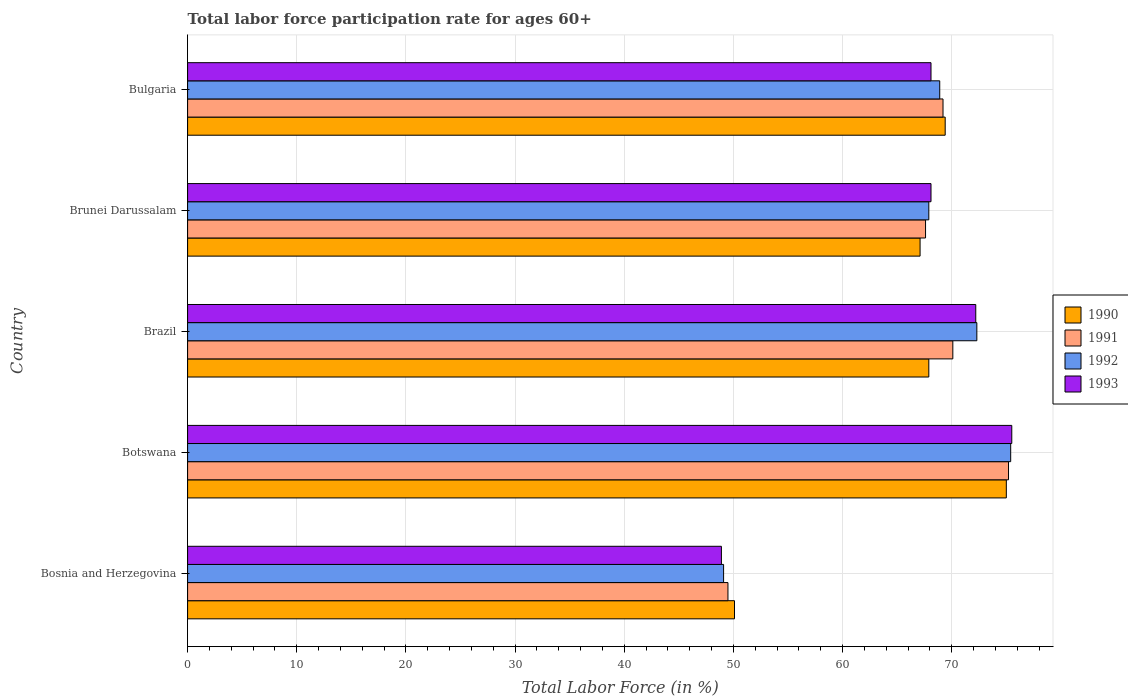How many groups of bars are there?
Provide a succinct answer. 5. Are the number of bars per tick equal to the number of legend labels?
Provide a short and direct response. Yes. Are the number of bars on each tick of the Y-axis equal?
Offer a terse response. Yes. How many bars are there on the 3rd tick from the top?
Your response must be concise. 4. What is the label of the 5th group of bars from the top?
Your answer should be compact. Bosnia and Herzegovina. In how many cases, is the number of bars for a given country not equal to the number of legend labels?
Make the answer very short. 0. What is the labor force participation rate in 1992 in Brazil?
Ensure brevity in your answer.  72.3. Across all countries, what is the maximum labor force participation rate in 1991?
Your answer should be very brief. 75.2. Across all countries, what is the minimum labor force participation rate in 1990?
Your response must be concise. 50.1. In which country was the labor force participation rate in 1990 maximum?
Your answer should be very brief. Botswana. In which country was the labor force participation rate in 1990 minimum?
Give a very brief answer. Bosnia and Herzegovina. What is the total labor force participation rate in 1990 in the graph?
Ensure brevity in your answer.  329.5. What is the difference between the labor force participation rate in 1991 in Bosnia and Herzegovina and that in Brunei Darussalam?
Offer a very short reply. -18.1. What is the difference between the labor force participation rate in 1990 in Botswana and the labor force participation rate in 1992 in Bulgaria?
Your answer should be very brief. 6.1. What is the average labor force participation rate in 1992 per country?
Offer a terse response. 66.72. What is the ratio of the labor force participation rate in 1991 in Botswana to that in Bulgaria?
Make the answer very short. 1.09. Is the labor force participation rate in 1991 in Bosnia and Herzegovina less than that in Botswana?
Your response must be concise. Yes. What is the difference between the highest and the second highest labor force participation rate in 1993?
Provide a short and direct response. 3.3. What is the difference between the highest and the lowest labor force participation rate in 1991?
Ensure brevity in your answer.  25.7. In how many countries, is the labor force participation rate in 1992 greater than the average labor force participation rate in 1992 taken over all countries?
Your answer should be compact. 4. Is it the case that in every country, the sum of the labor force participation rate in 1992 and labor force participation rate in 1993 is greater than the sum of labor force participation rate in 1991 and labor force participation rate in 1990?
Keep it short and to the point. No. What does the 4th bar from the bottom in Brunei Darussalam represents?
Ensure brevity in your answer.  1993. Is it the case that in every country, the sum of the labor force participation rate in 1993 and labor force participation rate in 1990 is greater than the labor force participation rate in 1992?
Your response must be concise. Yes. How many countries are there in the graph?
Give a very brief answer. 5. What is the difference between two consecutive major ticks on the X-axis?
Provide a short and direct response. 10. Where does the legend appear in the graph?
Offer a very short reply. Center right. How are the legend labels stacked?
Offer a terse response. Vertical. What is the title of the graph?
Provide a succinct answer. Total labor force participation rate for ages 60+. What is the Total Labor Force (in %) of 1990 in Bosnia and Herzegovina?
Give a very brief answer. 50.1. What is the Total Labor Force (in %) in 1991 in Bosnia and Herzegovina?
Keep it short and to the point. 49.5. What is the Total Labor Force (in %) in 1992 in Bosnia and Herzegovina?
Provide a succinct answer. 49.1. What is the Total Labor Force (in %) in 1993 in Bosnia and Herzegovina?
Make the answer very short. 48.9. What is the Total Labor Force (in %) in 1990 in Botswana?
Your response must be concise. 75. What is the Total Labor Force (in %) of 1991 in Botswana?
Keep it short and to the point. 75.2. What is the Total Labor Force (in %) in 1992 in Botswana?
Give a very brief answer. 75.4. What is the Total Labor Force (in %) in 1993 in Botswana?
Offer a very short reply. 75.5. What is the Total Labor Force (in %) of 1990 in Brazil?
Ensure brevity in your answer.  67.9. What is the Total Labor Force (in %) of 1991 in Brazil?
Offer a terse response. 70.1. What is the Total Labor Force (in %) in 1992 in Brazil?
Offer a terse response. 72.3. What is the Total Labor Force (in %) in 1993 in Brazil?
Provide a succinct answer. 72.2. What is the Total Labor Force (in %) of 1990 in Brunei Darussalam?
Make the answer very short. 67.1. What is the Total Labor Force (in %) of 1991 in Brunei Darussalam?
Keep it short and to the point. 67.6. What is the Total Labor Force (in %) in 1992 in Brunei Darussalam?
Your response must be concise. 67.9. What is the Total Labor Force (in %) of 1993 in Brunei Darussalam?
Ensure brevity in your answer.  68.1. What is the Total Labor Force (in %) of 1990 in Bulgaria?
Ensure brevity in your answer.  69.4. What is the Total Labor Force (in %) of 1991 in Bulgaria?
Offer a terse response. 69.2. What is the Total Labor Force (in %) of 1992 in Bulgaria?
Provide a succinct answer. 68.9. What is the Total Labor Force (in %) of 1993 in Bulgaria?
Keep it short and to the point. 68.1. Across all countries, what is the maximum Total Labor Force (in %) in 1990?
Provide a succinct answer. 75. Across all countries, what is the maximum Total Labor Force (in %) of 1991?
Offer a terse response. 75.2. Across all countries, what is the maximum Total Labor Force (in %) in 1992?
Give a very brief answer. 75.4. Across all countries, what is the maximum Total Labor Force (in %) of 1993?
Provide a short and direct response. 75.5. Across all countries, what is the minimum Total Labor Force (in %) of 1990?
Offer a terse response. 50.1. Across all countries, what is the minimum Total Labor Force (in %) of 1991?
Provide a short and direct response. 49.5. Across all countries, what is the minimum Total Labor Force (in %) of 1992?
Ensure brevity in your answer.  49.1. Across all countries, what is the minimum Total Labor Force (in %) in 1993?
Offer a very short reply. 48.9. What is the total Total Labor Force (in %) of 1990 in the graph?
Provide a short and direct response. 329.5. What is the total Total Labor Force (in %) of 1991 in the graph?
Offer a terse response. 331.6. What is the total Total Labor Force (in %) of 1992 in the graph?
Your answer should be compact. 333.6. What is the total Total Labor Force (in %) of 1993 in the graph?
Keep it short and to the point. 332.8. What is the difference between the Total Labor Force (in %) of 1990 in Bosnia and Herzegovina and that in Botswana?
Your answer should be compact. -24.9. What is the difference between the Total Labor Force (in %) of 1991 in Bosnia and Herzegovina and that in Botswana?
Give a very brief answer. -25.7. What is the difference between the Total Labor Force (in %) in 1992 in Bosnia and Herzegovina and that in Botswana?
Keep it short and to the point. -26.3. What is the difference between the Total Labor Force (in %) of 1993 in Bosnia and Herzegovina and that in Botswana?
Your answer should be very brief. -26.6. What is the difference between the Total Labor Force (in %) in 1990 in Bosnia and Herzegovina and that in Brazil?
Make the answer very short. -17.8. What is the difference between the Total Labor Force (in %) in 1991 in Bosnia and Herzegovina and that in Brazil?
Offer a terse response. -20.6. What is the difference between the Total Labor Force (in %) of 1992 in Bosnia and Herzegovina and that in Brazil?
Provide a short and direct response. -23.2. What is the difference between the Total Labor Force (in %) of 1993 in Bosnia and Herzegovina and that in Brazil?
Offer a terse response. -23.3. What is the difference between the Total Labor Force (in %) of 1990 in Bosnia and Herzegovina and that in Brunei Darussalam?
Make the answer very short. -17. What is the difference between the Total Labor Force (in %) in 1991 in Bosnia and Herzegovina and that in Brunei Darussalam?
Your answer should be very brief. -18.1. What is the difference between the Total Labor Force (in %) in 1992 in Bosnia and Herzegovina and that in Brunei Darussalam?
Your answer should be very brief. -18.8. What is the difference between the Total Labor Force (in %) in 1993 in Bosnia and Herzegovina and that in Brunei Darussalam?
Give a very brief answer. -19.2. What is the difference between the Total Labor Force (in %) in 1990 in Bosnia and Herzegovina and that in Bulgaria?
Make the answer very short. -19.3. What is the difference between the Total Labor Force (in %) of 1991 in Bosnia and Herzegovina and that in Bulgaria?
Give a very brief answer. -19.7. What is the difference between the Total Labor Force (in %) in 1992 in Bosnia and Herzegovina and that in Bulgaria?
Keep it short and to the point. -19.8. What is the difference between the Total Labor Force (in %) of 1993 in Bosnia and Herzegovina and that in Bulgaria?
Provide a succinct answer. -19.2. What is the difference between the Total Labor Force (in %) in 1993 in Botswana and that in Brazil?
Your answer should be very brief. 3.3. What is the difference between the Total Labor Force (in %) of 1990 in Botswana and that in Brunei Darussalam?
Your answer should be compact. 7.9. What is the difference between the Total Labor Force (in %) in 1991 in Botswana and that in Brunei Darussalam?
Your answer should be very brief. 7.6. What is the difference between the Total Labor Force (in %) in 1993 in Botswana and that in Brunei Darussalam?
Provide a short and direct response. 7.4. What is the difference between the Total Labor Force (in %) of 1990 in Botswana and that in Bulgaria?
Ensure brevity in your answer.  5.6. What is the difference between the Total Labor Force (in %) of 1993 in Botswana and that in Bulgaria?
Make the answer very short. 7.4. What is the difference between the Total Labor Force (in %) in 1990 in Brazil and that in Brunei Darussalam?
Make the answer very short. 0.8. What is the difference between the Total Labor Force (in %) of 1993 in Brazil and that in Brunei Darussalam?
Provide a succinct answer. 4.1. What is the difference between the Total Labor Force (in %) of 1992 in Brazil and that in Bulgaria?
Provide a succinct answer. 3.4. What is the difference between the Total Labor Force (in %) of 1991 in Brunei Darussalam and that in Bulgaria?
Provide a short and direct response. -1.6. What is the difference between the Total Labor Force (in %) of 1992 in Brunei Darussalam and that in Bulgaria?
Your answer should be very brief. -1. What is the difference between the Total Labor Force (in %) of 1993 in Brunei Darussalam and that in Bulgaria?
Offer a terse response. 0. What is the difference between the Total Labor Force (in %) in 1990 in Bosnia and Herzegovina and the Total Labor Force (in %) in 1991 in Botswana?
Offer a terse response. -25.1. What is the difference between the Total Labor Force (in %) in 1990 in Bosnia and Herzegovina and the Total Labor Force (in %) in 1992 in Botswana?
Give a very brief answer. -25.3. What is the difference between the Total Labor Force (in %) in 1990 in Bosnia and Herzegovina and the Total Labor Force (in %) in 1993 in Botswana?
Give a very brief answer. -25.4. What is the difference between the Total Labor Force (in %) in 1991 in Bosnia and Herzegovina and the Total Labor Force (in %) in 1992 in Botswana?
Your answer should be compact. -25.9. What is the difference between the Total Labor Force (in %) in 1991 in Bosnia and Herzegovina and the Total Labor Force (in %) in 1993 in Botswana?
Keep it short and to the point. -26. What is the difference between the Total Labor Force (in %) of 1992 in Bosnia and Herzegovina and the Total Labor Force (in %) of 1993 in Botswana?
Make the answer very short. -26.4. What is the difference between the Total Labor Force (in %) of 1990 in Bosnia and Herzegovina and the Total Labor Force (in %) of 1991 in Brazil?
Make the answer very short. -20. What is the difference between the Total Labor Force (in %) in 1990 in Bosnia and Herzegovina and the Total Labor Force (in %) in 1992 in Brazil?
Ensure brevity in your answer.  -22.2. What is the difference between the Total Labor Force (in %) of 1990 in Bosnia and Herzegovina and the Total Labor Force (in %) of 1993 in Brazil?
Your answer should be compact. -22.1. What is the difference between the Total Labor Force (in %) of 1991 in Bosnia and Herzegovina and the Total Labor Force (in %) of 1992 in Brazil?
Your response must be concise. -22.8. What is the difference between the Total Labor Force (in %) in 1991 in Bosnia and Herzegovina and the Total Labor Force (in %) in 1993 in Brazil?
Keep it short and to the point. -22.7. What is the difference between the Total Labor Force (in %) of 1992 in Bosnia and Herzegovina and the Total Labor Force (in %) of 1993 in Brazil?
Your answer should be very brief. -23.1. What is the difference between the Total Labor Force (in %) of 1990 in Bosnia and Herzegovina and the Total Labor Force (in %) of 1991 in Brunei Darussalam?
Your answer should be compact. -17.5. What is the difference between the Total Labor Force (in %) in 1990 in Bosnia and Herzegovina and the Total Labor Force (in %) in 1992 in Brunei Darussalam?
Make the answer very short. -17.8. What is the difference between the Total Labor Force (in %) in 1991 in Bosnia and Herzegovina and the Total Labor Force (in %) in 1992 in Brunei Darussalam?
Your answer should be very brief. -18.4. What is the difference between the Total Labor Force (in %) of 1991 in Bosnia and Herzegovina and the Total Labor Force (in %) of 1993 in Brunei Darussalam?
Ensure brevity in your answer.  -18.6. What is the difference between the Total Labor Force (in %) of 1992 in Bosnia and Herzegovina and the Total Labor Force (in %) of 1993 in Brunei Darussalam?
Provide a short and direct response. -19. What is the difference between the Total Labor Force (in %) in 1990 in Bosnia and Herzegovina and the Total Labor Force (in %) in 1991 in Bulgaria?
Ensure brevity in your answer.  -19.1. What is the difference between the Total Labor Force (in %) in 1990 in Bosnia and Herzegovina and the Total Labor Force (in %) in 1992 in Bulgaria?
Make the answer very short. -18.8. What is the difference between the Total Labor Force (in %) in 1991 in Bosnia and Herzegovina and the Total Labor Force (in %) in 1992 in Bulgaria?
Offer a very short reply. -19.4. What is the difference between the Total Labor Force (in %) in 1991 in Bosnia and Herzegovina and the Total Labor Force (in %) in 1993 in Bulgaria?
Provide a short and direct response. -18.6. What is the difference between the Total Labor Force (in %) in 1992 in Bosnia and Herzegovina and the Total Labor Force (in %) in 1993 in Bulgaria?
Provide a short and direct response. -19. What is the difference between the Total Labor Force (in %) of 1990 in Botswana and the Total Labor Force (in %) of 1991 in Brazil?
Your answer should be very brief. 4.9. What is the difference between the Total Labor Force (in %) of 1990 in Botswana and the Total Labor Force (in %) of 1992 in Brazil?
Provide a short and direct response. 2.7. What is the difference between the Total Labor Force (in %) of 1991 in Botswana and the Total Labor Force (in %) of 1992 in Brazil?
Your response must be concise. 2.9. What is the difference between the Total Labor Force (in %) in 1992 in Botswana and the Total Labor Force (in %) in 1993 in Brazil?
Ensure brevity in your answer.  3.2. What is the difference between the Total Labor Force (in %) of 1991 in Botswana and the Total Labor Force (in %) of 1993 in Brunei Darussalam?
Offer a terse response. 7.1. What is the difference between the Total Labor Force (in %) in 1991 in Botswana and the Total Labor Force (in %) in 1993 in Bulgaria?
Keep it short and to the point. 7.1. What is the difference between the Total Labor Force (in %) in 1992 in Botswana and the Total Labor Force (in %) in 1993 in Bulgaria?
Your answer should be very brief. 7.3. What is the difference between the Total Labor Force (in %) of 1990 in Brazil and the Total Labor Force (in %) of 1991 in Brunei Darussalam?
Your response must be concise. 0.3. What is the difference between the Total Labor Force (in %) of 1990 in Brazil and the Total Labor Force (in %) of 1993 in Brunei Darussalam?
Your answer should be very brief. -0.2. What is the difference between the Total Labor Force (in %) in 1991 in Brazil and the Total Labor Force (in %) in 1992 in Brunei Darussalam?
Provide a short and direct response. 2.2. What is the difference between the Total Labor Force (in %) in 1990 in Brazil and the Total Labor Force (in %) in 1992 in Bulgaria?
Your answer should be compact. -1. What is the difference between the Total Labor Force (in %) of 1991 in Brazil and the Total Labor Force (in %) of 1993 in Bulgaria?
Your answer should be compact. 2. What is the difference between the Total Labor Force (in %) of 1992 in Brazil and the Total Labor Force (in %) of 1993 in Bulgaria?
Offer a terse response. 4.2. What is the difference between the Total Labor Force (in %) of 1990 in Brunei Darussalam and the Total Labor Force (in %) of 1992 in Bulgaria?
Offer a very short reply. -1.8. What is the difference between the Total Labor Force (in %) of 1992 in Brunei Darussalam and the Total Labor Force (in %) of 1993 in Bulgaria?
Provide a short and direct response. -0.2. What is the average Total Labor Force (in %) of 1990 per country?
Provide a short and direct response. 65.9. What is the average Total Labor Force (in %) in 1991 per country?
Your response must be concise. 66.32. What is the average Total Labor Force (in %) of 1992 per country?
Make the answer very short. 66.72. What is the average Total Labor Force (in %) of 1993 per country?
Make the answer very short. 66.56. What is the difference between the Total Labor Force (in %) in 1990 and Total Labor Force (in %) in 1993 in Bosnia and Herzegovina?
Your answer should be very brief. 1.2. What is the difference between the Total Labor Force (in %) of 1991 and Total Labor Force (in %) of 1992 in Bosnia and Herzegovina?
Your answer should be compact. 0.4. What is the difference between the Total Labor Force (in %) in 1991 and Total Labor Force (in %) in 1993 in Bosnia and Herzegovina?
Your answer should be very brief. 0.6. What is the difference between the Total Labor Force (in %) of 1990 and Total Labor Force (in %) of 1991 in Botswana?
Give a very brief answer. -0.2. What is the difference between the Total Labor Force (in %) of 1990 and Total Labor Force (in %) of 1992 in Botswana?
Your answer should be compact. -0.4. What is the difference between the Total Labor Force (in %) in 1990 and Total Labor Force (in %) in 1993 in Brazil?
Give a very brief answer. -4.3. What is the difference between the Total Labor Force (in %) of 1991 and Total Labor Force (in %) of 1992 in Brazil?
Ensure brevity in your answer.  -2.2. What is the difference between the Total Labor Force (in %) in 1991 and Total Labor Force (in %) in 1993 in Brazil?
Ensure brevity in your answer.  -2.1. What is the difference between the Total Labor Force (in %) of 1990 and Total Labor Force (in %) of 1992 in Brunei Darussalam?
Give a very brief answer. -0.8. What is the difference between the Total Labor Force (in %) in 1990 and Total Labor Force (in %) in 1993 in Brunei Darussalam?
Provide a short and direct response. -1. What is the difference between the Total Labor Force (in %) of 1990 and Total Labor Force (in %) of 1991 in Bulgaria?
Your answer should be compact. 0.2. What is the difference between the Total Labor Force (in %) in 1990 and Total Labor Force (in %) in 1993 in Bulgaria?
Provide a short and direct response. 1.3. What is the difference between the Total Labor Force (in %) of 1992 and Total Labor Force (in %) of 1993 in Bulgaria?
Give a very brief answer. 0.8. What is the ratio of the Total Labor Force (in %) in 1990 in Bosnia and Herzegovina to that in Botswana?
Offer a terse response. 0.67. What is the ratio of the Total Labor Force (in %) of 1991 in Bosnia and Herzegovina to that in Botswana?
Ensure brevity in your answer.  0.66. What is the ratio of the Total Labor Force (in %) of 1992 in Bosnia and Herzegovina to that in Botswana?
Provide a succinct answer. 0.65. What is the ratio of the Total Labor Force (in %) in 1993 in Bosnia and Herzegovina to that in Botswana?
Provide a succinct answer. 0.65. What is the ratio of the Total Labor Force (in %) of 1990 in Bosnia and Herzegovina to that in Brazil?
Your response must be concise. 0.74. What is the ratio of the Total Labor Force (in %) of 1991 in Bosnia and Herzegovina to that in Brazil?
Your answer should be compact. 0.71. What is the ratio of the Total Labor Force (in %) in 1992 in Bosnia and Herzegovina to that in Brazil?
Your response must be concise. 0.68. What is the ratio of the Total Labor Force (in %) in 1993 in Bosnia and Herzegovina to that in Brazil?
Your answer should be very brief. 0.68. What is the ratio of the Total Labor Force (in %) of 1990 in Bosnia and Herzegovina to that in Brunei Darussalam?
Ensure brevity in your answer.  0.75. What is the ratio of the Total Labor Force (in %) in 1991 in Bosnia and Herzegovina to that in Brunei Darussalam?
Your response must be concise. 0.73. What is the ratio of the Total Labor Force (in %) of 1992 in Bosnia and Herzegovina to that in Brunei Darussalam?
Make the answer very short. 0.72. What is the ratio of the Total Labor Force (in %) of 1993 in Bosnia and Herzegovina to that in Brunei Darussalam?
Give a very brief answer. 0.72. What is the ratio of the Total Labor Force (in %) of 1990 in Bosnia and Herzegovina to that in Bulgaria?
Provide a succinct answer. 0.72. What is the ratio of the Total Labor Force (in %) in 1991 in Bosnia and Herzegovina to that in Bulgaria?
Make the answer very short. 0.72. What is the ratio of the Total Labor Force (in %) of 1992 in Bosnia and Herzegovina to that in Bulgaria?
Keep it short and to the point. 0.71. What is the ratio of the Total Labor Force (in %) of 1993 in Bosnia and Herzegovina to that in Bulgaria?
Ensure brevity in your answer.  0.72. What is the ratio of the Total Labor Force (in %) in 1990 in Botswana to that in Brazil?
Make the answer very short. 1.1. What is the ratio of the Total Labor Force (in %) of 1991 in Botswana to that in Brazil?
Offer a very short reply. 1.07. What is the ratio of the Total Labor Force (in %) of 1992 in Botswana to that in Brazil?
Your answer should be compact. 1.04. What is the ratio of the Total Labor Force (in %) of 1993 in Botswana to that in Brazil?
Provide a short and direct response. 1.05. What is the ratio of the Total Labor Force (in %) of 1990 in Botswana to that in Brunei Darussalam?
Offer a very short reply. 1.12. What is the ratio of the Total Labor Force (in %) in 1991 in Botswana to that in Brunei Darussalam?
Your answer should be compact. 1.11. What is the ratio of the Total Labor Force (in %) in 1992 in Botswana to that in Brunei Darussalam?
Your answer should be compact. 1.11. What is the ratio of the Total Labor Force (in %) of 1993 in Botswana to that in Brunei Darussalam?
Your response must be concise. 1.11. What is the ratio of the Total Labor Force (in %) in 1990 in Botswana to that in Bulgaria?
Offer a terse response. 1.08. What is the ratio of the Total Labor Force (in %) in 1991 in Botswana to that in Bulgaria?
Ensure brevity in your answer.  1.09. What is the ratio of the Total Labor Force (in %) in 1992 in Botswana to that in Bulgaria?
Provide a succinct answer. 1.09. What is the ratio of the Total Labor Force (in %) in 1993 in Botswana to that in Bulgaria?
Your answer should be very brief. 1.11. What is the ratio of the Total Labor Force (in %) in 1990 in Brazil to that in Brunei Darussalam?
Your answer should be very brief. 1.01. What is the ratio of the Total Labor Force (in %) in 1992 in Brazil to that in Brunei Darussalam?
Make the answer very short. 1.06. What is the ratio of the Total Labor Force (in %) in 1993 in Brazil to that in Brunei Darussalam?
Keep it short and to the point. 1.06. What is the ratio of the Total Labor Force (in %) of 1990 in Brazil to that in Bulgaria?
Your answer should be compact. 0.98. What is the ratio of the Total Labor Force (in %) in 1991 in Brazil to that in Bulgaria?
Keep it short and to the point. 1.01. What is the ratio of the Total Labor Force (in %) in 1992 in Brazil to that in Bulgaria?
Keep it short and to the point. 1.05. What is the ratio of the Total Labor Force (in %) in 1993 in Brazil to that in Bulgaria?
Ensure brevity in your answer.  1.06. What is the ratio of the Total Labor Force (in %) of 1990 in Brunei Darussalam to that in Bulgaria?
Provide a succinct answer. 0.97. What is the ratio of the Total Labor Force (in %) of 1991 in Brunei Darussalam to that in Bulgaria?
Your answer should be compact. 0.98. What is the ratio of the Total Labor Force (in %) of 1992 in Brunei Darussalam to that in Bulgaria?
Provide a short and direct response. 0.99. What is the ratio of the Total Labor Force (in %) in 1993 in Brunei Darussalam to that in Bulgaria?
Offer a terse response. 1. What is the difference between the highest and the second highest Total Labor Force (in %) in 1992?
Make the answer very short. 3.1. What is the difference between the highest and the second highest Total Labor Force (in %) of 1993?
Provide a short and direct response. 3.3. What is the difference between the highest and the lowest Total Labor Force (in %) in 1990?
Make the answer very short. 24.9. What is the difference between the highest and the lowest Total Labor Force (in %) in 1991?
Make the answer very short. 25.7. What is the difference between the highest and the lowest Total Labor Force (in %) in 1992?
Provide a short and direct response. 26.3. What is the difference between the highest and the lowest Total Labor Force (in %) in 1993?
Give a very brief answer. 26.6. 